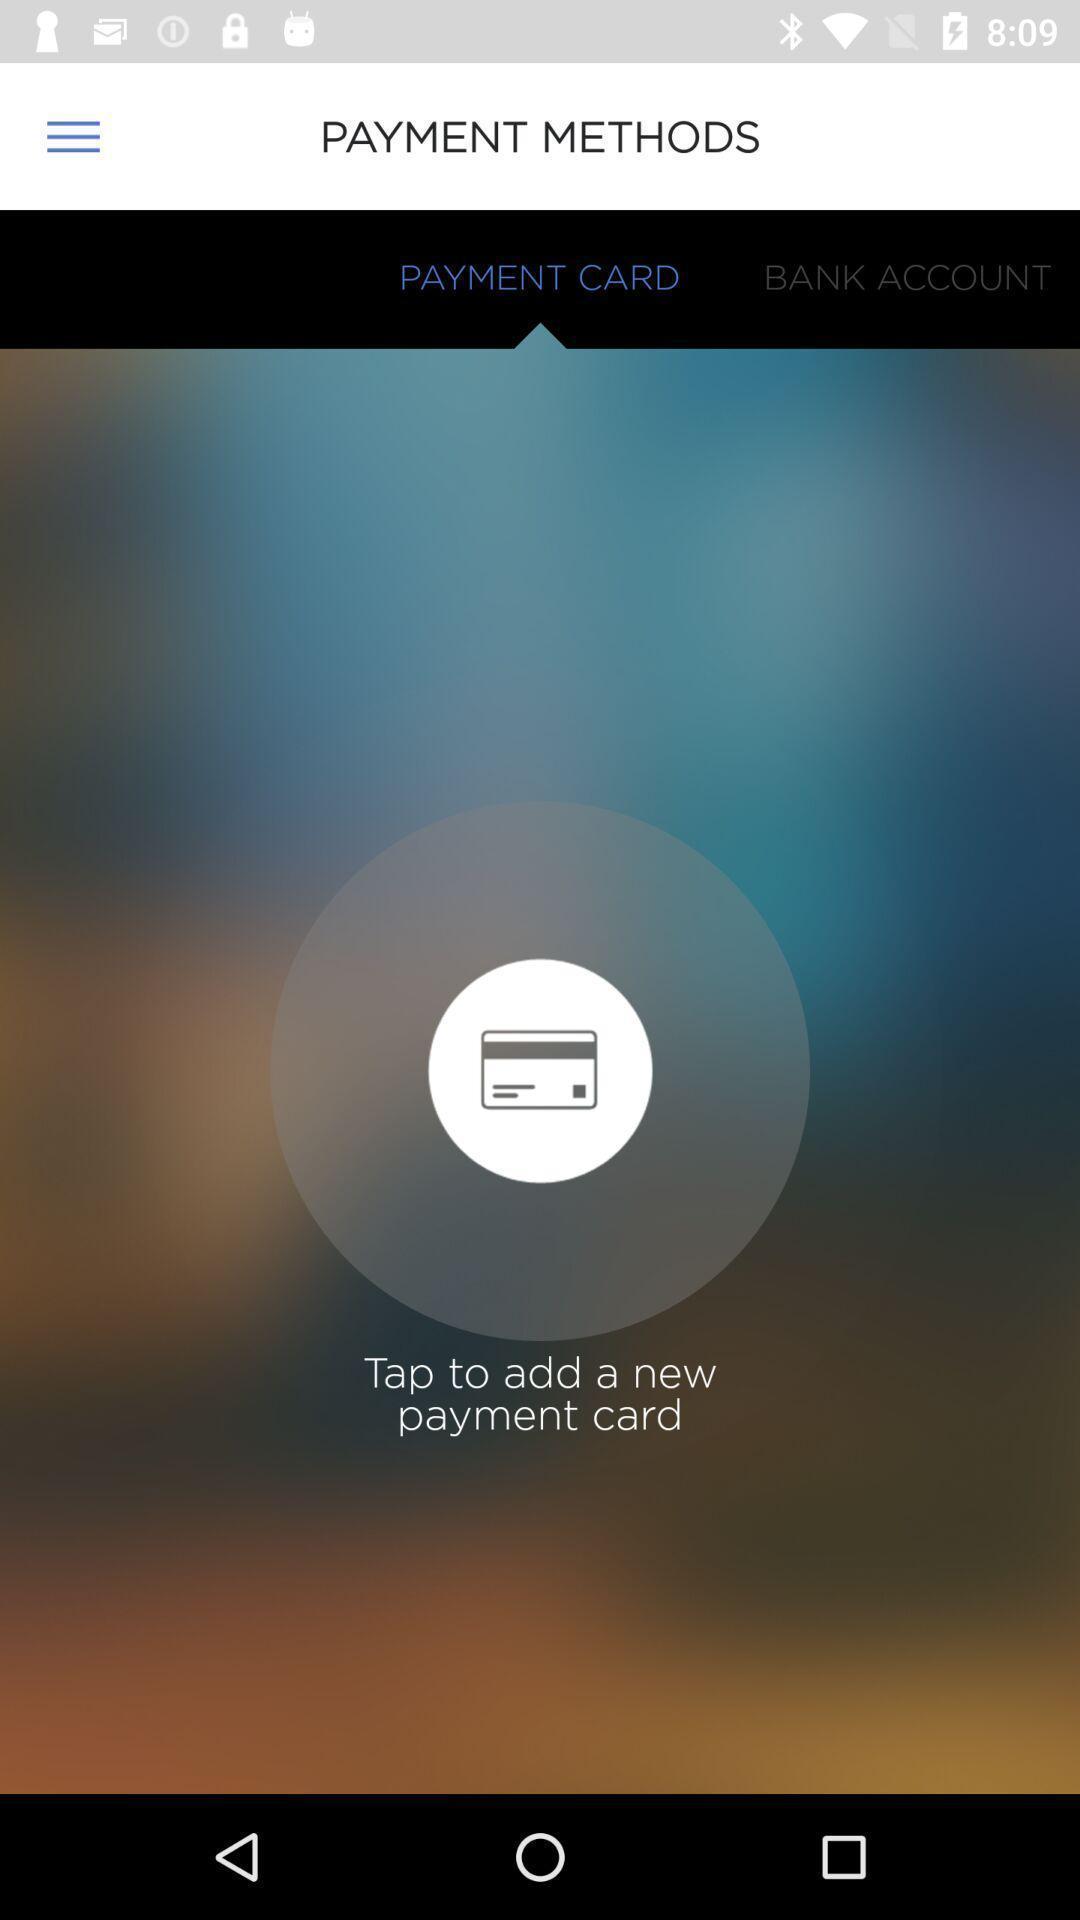Summarize the main components in this picture. Screen showing tap to add a new payment card. 